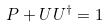Convert formula to latex. <formula><loc_0><loc_0><loc_500><loc_500>P + U U ^ { \dagger } = 1</formula> 